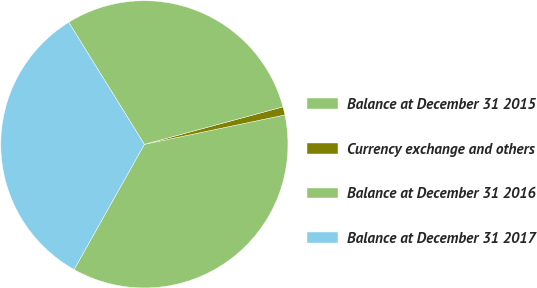<chart> <loc_0><loc_0><loc_500><loc_500><pie_chart><fcel>Balance at December 31 2015<fcel>Currency exchange and others<fcel>Balance at December 31 2016<fcel>Balance at December 31 2017<nl><fcel>36.42%<fcel>0.92%<fcel>29.63%<fcel>33.03%<nl></chart> 